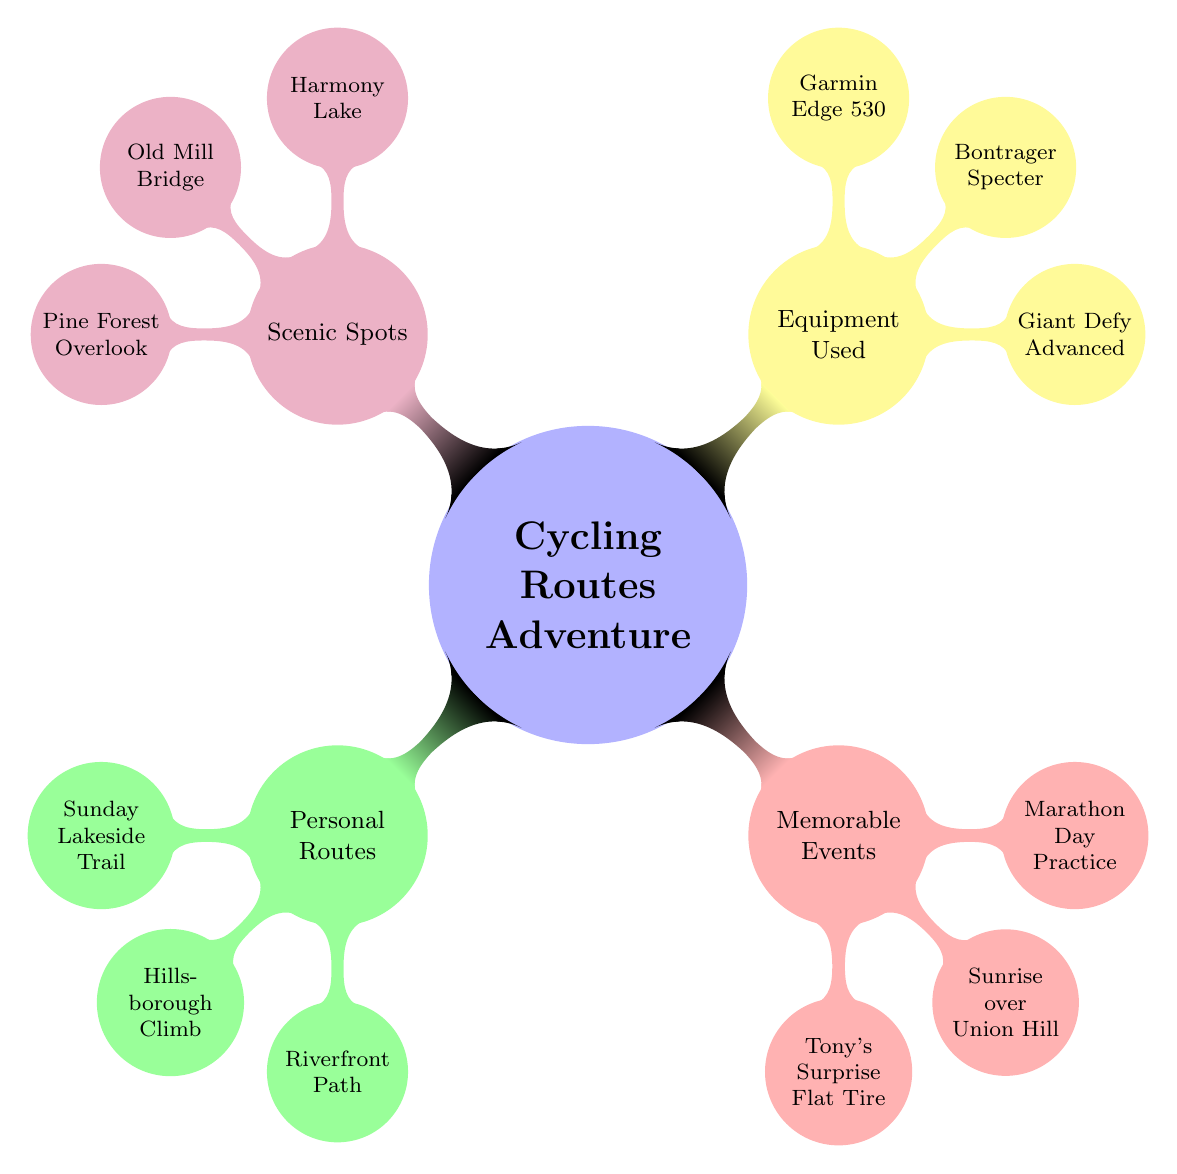What are the three personal routes listed? The diagram under the "Personal Routes" node lists three specific routes: "Sunday Lakeside Trail," "Hillsborough Climb," and "Riverfront Path."
Answer: Sunday Lakeside Trail, Hillsborough Climb, Riverfront Path How many memorable events are shown? The "Memorable Events" node of the diagram includes three separate events: "Tony's Surprise Flat Tire," "Sunrise over Union Hill," and "Marathon Day Practice," which can be counted.
Answer: 3 What type of bike is mentioned? Under the "Equipment Used" node, the diagram specifies the type of bike used as "Giant Defy Advanced."
Answer: Giant Defy Advanced Which scenic spot comes first in the list? The first scenic spot listed under the "Scenic Spots" node is "Harmony Lake." Therefore, it is identified as the one that appears first.
Answer: Harmony Lake What event relates to Tony and a tire? In the "Memorable Events" section, the event titled "Tony's Surprise Flat Tire" directly relates to Tony and the issue of a flat tire, demonstrating a specific event of interest.
Answer: Tony's Surprise Flat Tire Which equipment is used for navigation? The "Equipment Used" node lists "Garmin Edge 530" as the GPS device used for navigation during cycling, clearly indicating its purpose within the cycling context.
Answer: Garmin Edge 530 How many scenic spots are listed? The "Scenic Spots" node in the diagram presents three distinct locations: "Harmony Lake," "Old Mill Bridge," and "Pine Forest Overlook," which can be tallied for the total count.
Answer: 3 Which route is primarily about climbing? The "Hillsborough Climb" is specified explicitly in the "Personal Routes" node, indicating it is a route focused on climbing.
Answer: Hillsborough Climb What color represents memorable events in this mind map? The section labeled "Memorable Events" is represented in red, which can be identified clearly in the visual distinction of the nodes.
Answer: Red 